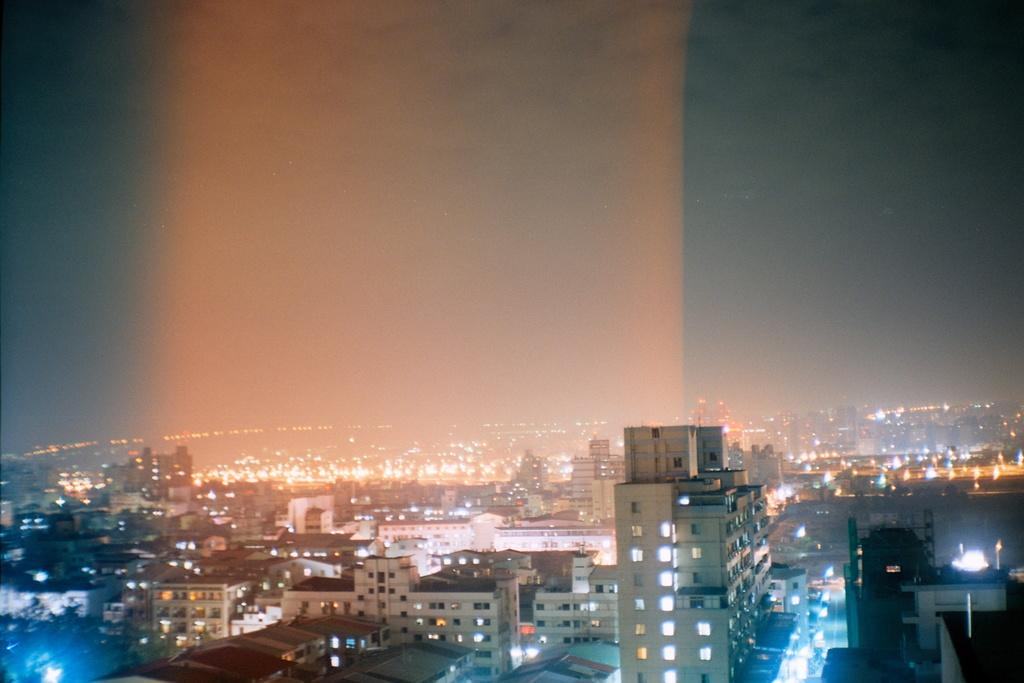What type of view is shown in the image? The image is an aerial view of a city. What can be seen on the ground in the image? There are lights and buildings visible in the image. What is visible in the background of the image? The sky is visible in the background of the image. What verse is being recited by the sister in the image? There is no sister or verse present in the image; it is an aerial view of a city with lights, buildings, and a visible sky. 